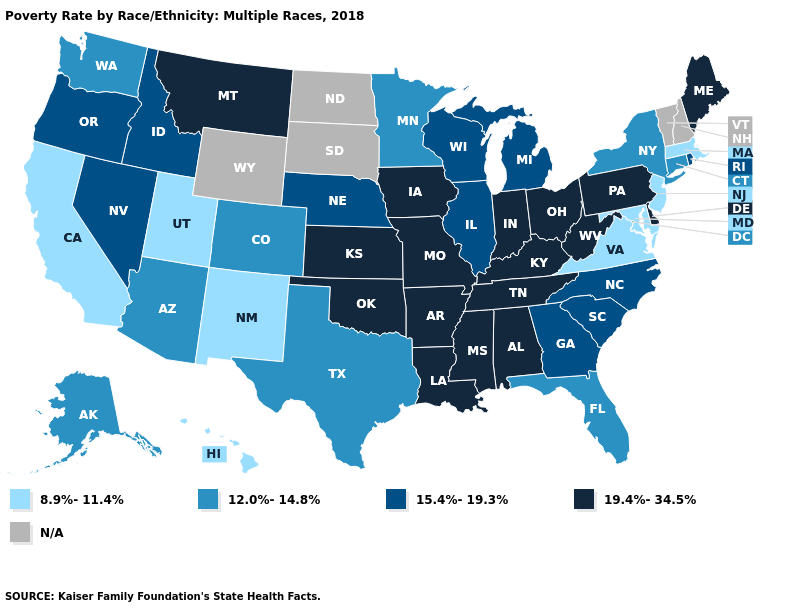Which states have the lowest value in the USA?
Keep it brief. California, Hawaii, Maryland, Massachusetts, New Jersey, New Mexico, Utah, Virginia. Which states have the highest value in the USA?
Short answer required. Alabama, Arkansas, Delaware, Indiana, Iowa, Kansas, Kentucky, Louisiana, Maine, Mississippi, Missouri, Montana, Ohio, Oklahoma, Pennsylvania, Tennessee, West Virginia. What is the value of North Dakota?
Write a very short answer. N/A. What is the value of Florida?
Concise answer only. 12.0%-14.8%. Among the states that border Vermont , which have the lowest value?
Write a very short answer. Massachusetts. Which states have the lowest value in the South?
Quick response, please. Maryland, Virginia. Name the states that have a value in the range 19.4%-34.5%?
Short answer required. Alabama, Arkansas, Delaware, Indiana, Iowa, Kansas, Kentucky, Louisiana, Maine, Mississippi, Missouri, Montana, Ohio, Oklahoma, Pennsylvania, Tennessee, West Virginia. What is the highest value in the Northeast ?
Give a very brief answer. 19.4%-34.5%. Among the states that border Iowa , which have the highest value?
Write a very short answer. Missouri. What is the lowest value in the West?
Concise answer only. 8.9%-11.4%. Does Kansas have the lowest value in the MidWest?
Be succinct. No. What is the value of Louisiana?
Quick response, please. 19.4%-34.5%. What is the value of Oklahoma?
Answer briefly. 19.4%-34.5%. Name the states that have a value in the range 15.4%-19.3%?
Quick response, please. Georgia, Idaho, Illinois, Michigan, Nebraska, Nevada, North Carolina, Oregon, Rhode Island, South Carolina, Wisconsin. Is the legend a continuous bar?
Concise answer only. No. 